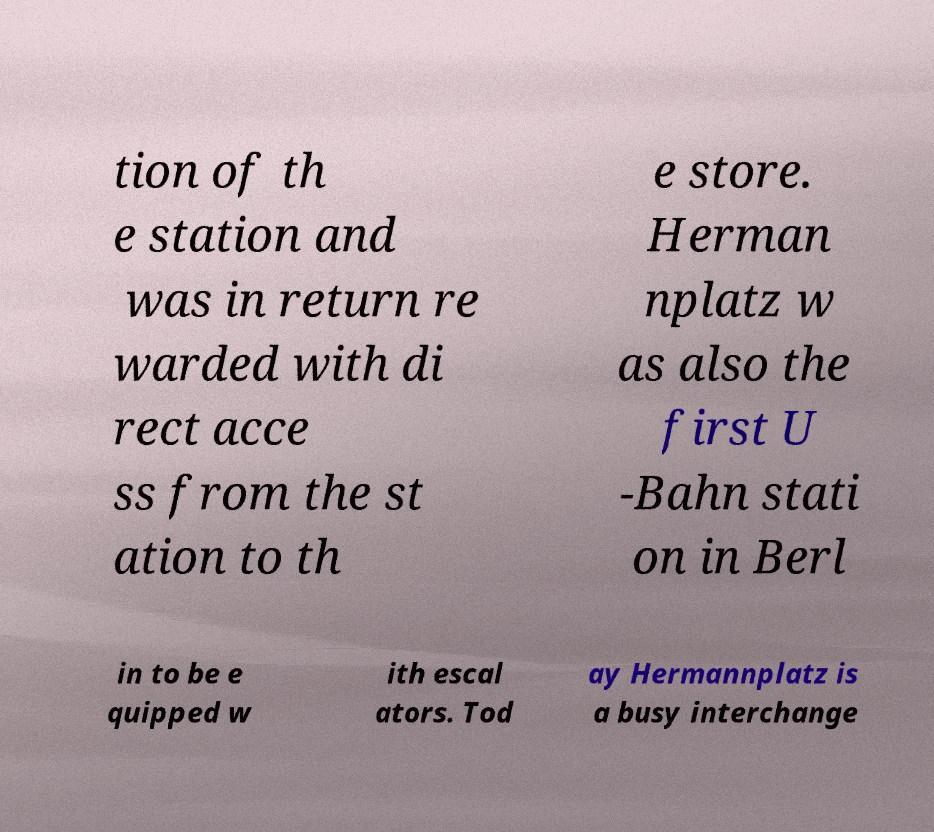There's text embedded in this image that I need extracted. Can you transcribe it verbatim? tion of th e station and was in return re warded with di rect acce ss from the st ation to th e store. Herman nplatz w as also the first U -Bahn stati on in Berl in to be e quipped w ith escal ators. Tod ay Hermannplatz is a busy interchange 